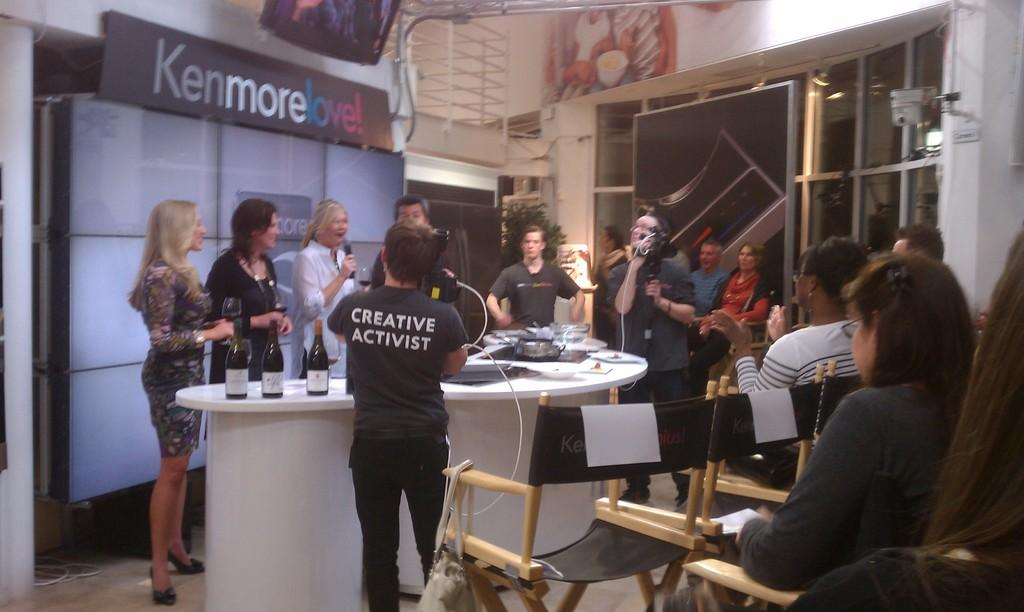What are the people in the image doing? There are persons standing and sitting in the image. Can you describe what one person is holding? One person is holding a camera. What objects can be seen on the table in the image? There are bottles and a container on a table. What type of linen or lace can be seen on the persons in the image? There is no mention of linen or lace in the image; the focus is on the persons standing, sitting, and holding a camera. 